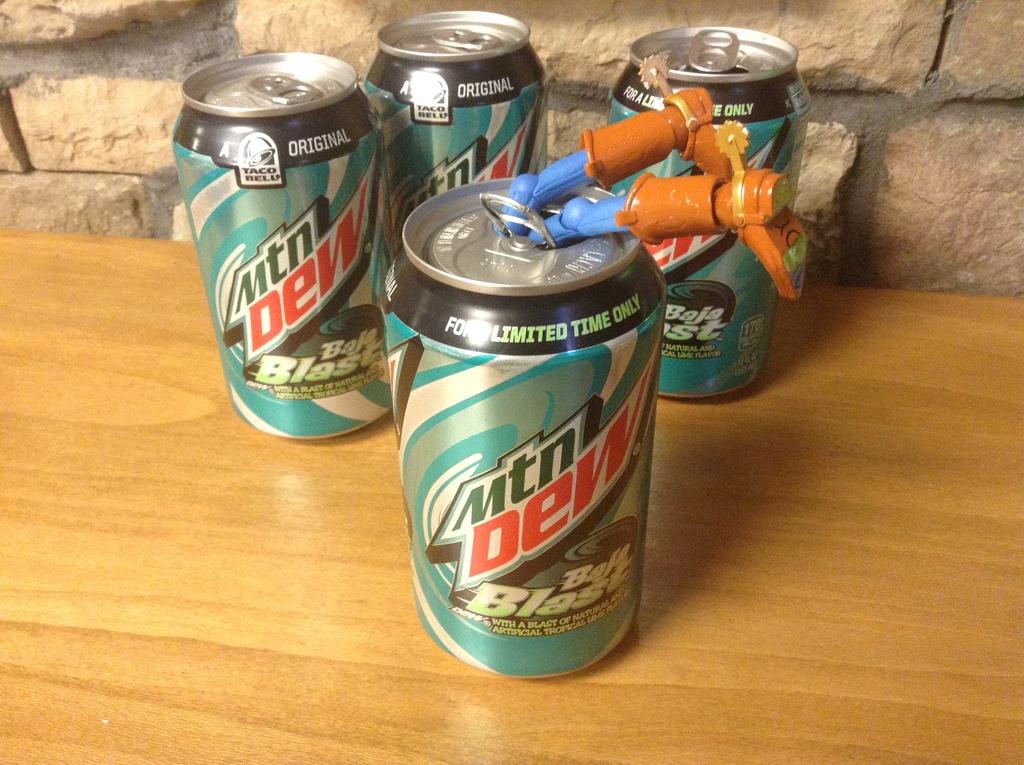What flavor is this drink?
Your answer should be compact. Baja blast. Are these cans for a limited time only?
Offer a very short reply. Yes. 